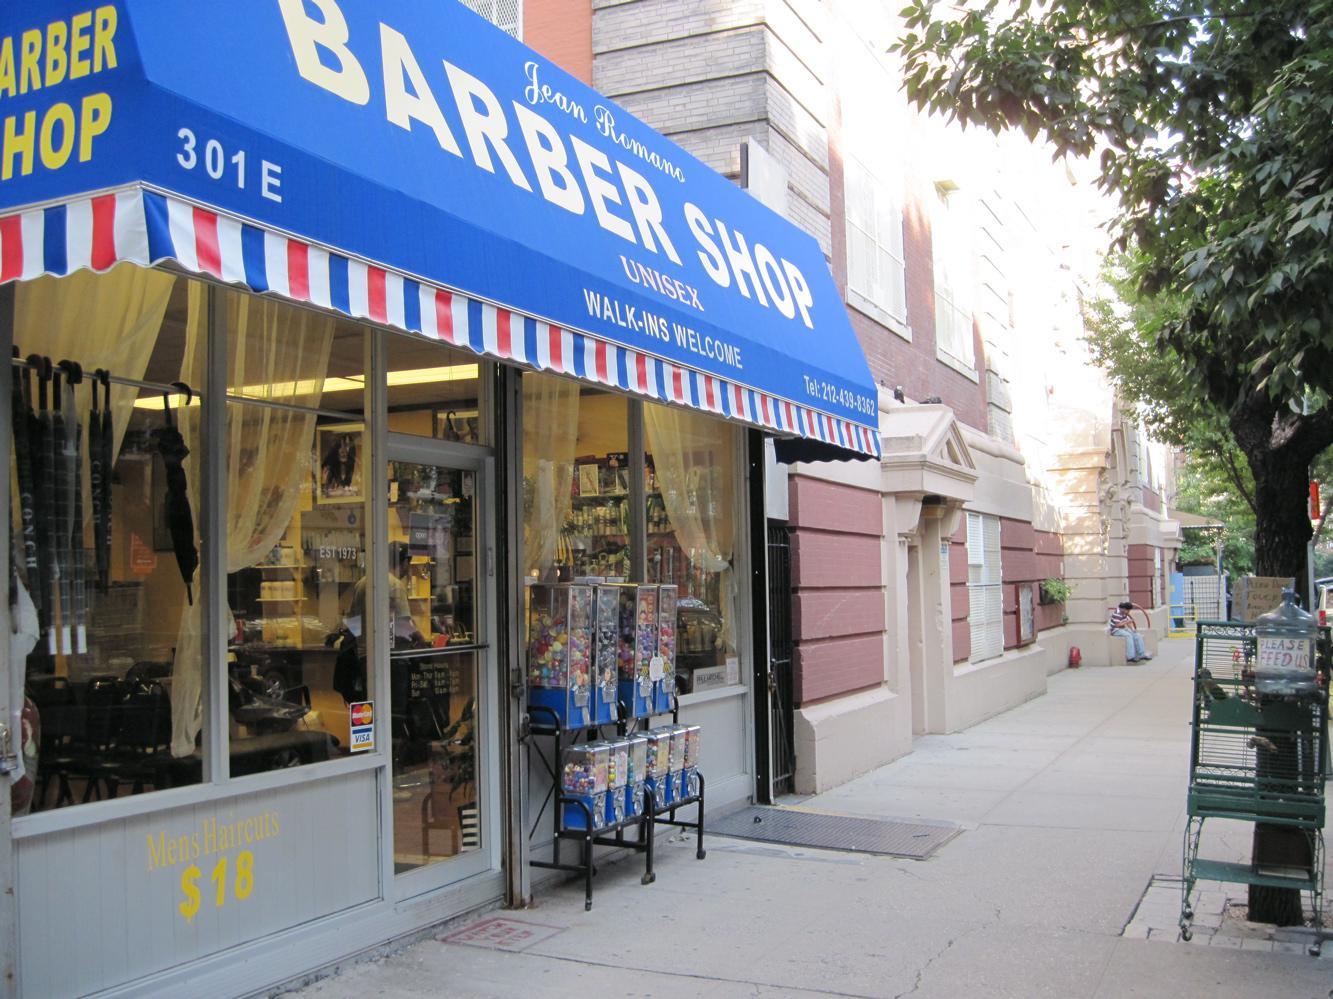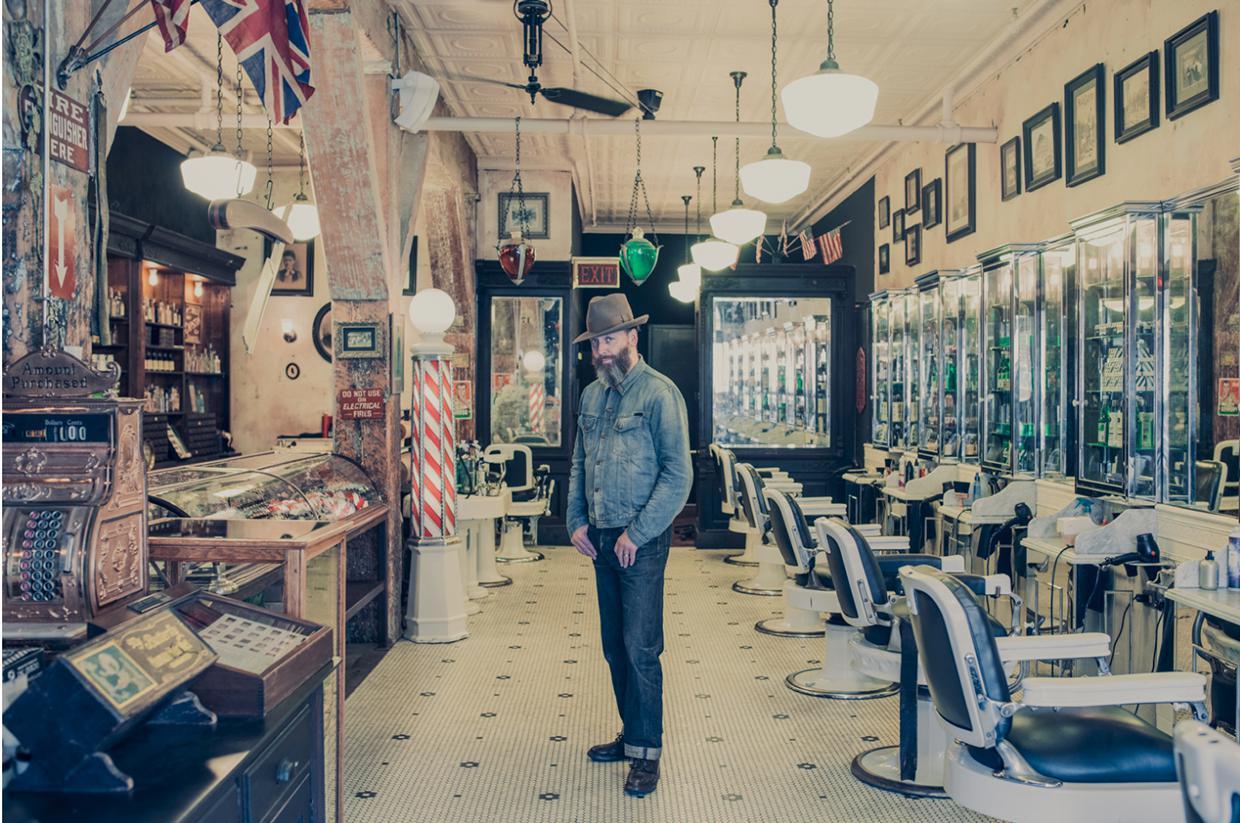The first image is the image on the left, the second image is the image on the right. Given the left and right images, does the statement "In at least one image there is a single man posing in the middle of a barber shop." hold true? Answer yes or no. Yes. 